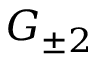<formula> <loc_0><loc_0><loc_500><loc_500>G _ { \pm 2 }</formula> 